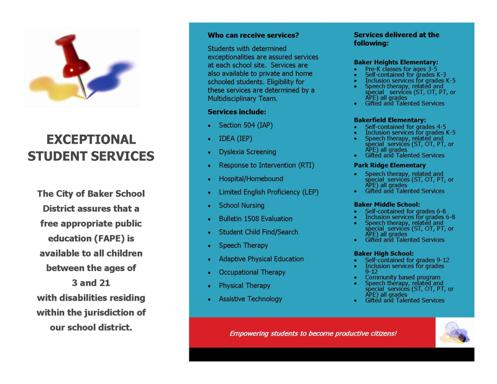What type of services are provided by the organization mentioned on the card? The organization highlighted on the card provides a comprehensive array of support services tailored for students with special needs. These services include educational plans under Section 504 and IDEA, Dyslexia Screening, and numerous therapies such as Speech and Occupational Therapy. They also focus on empowering students through the use of Assistive Technology, advancing them towards being productive citizens. Each service is crucial in fostering an inclusive educational environment that meets diverse student needs. 